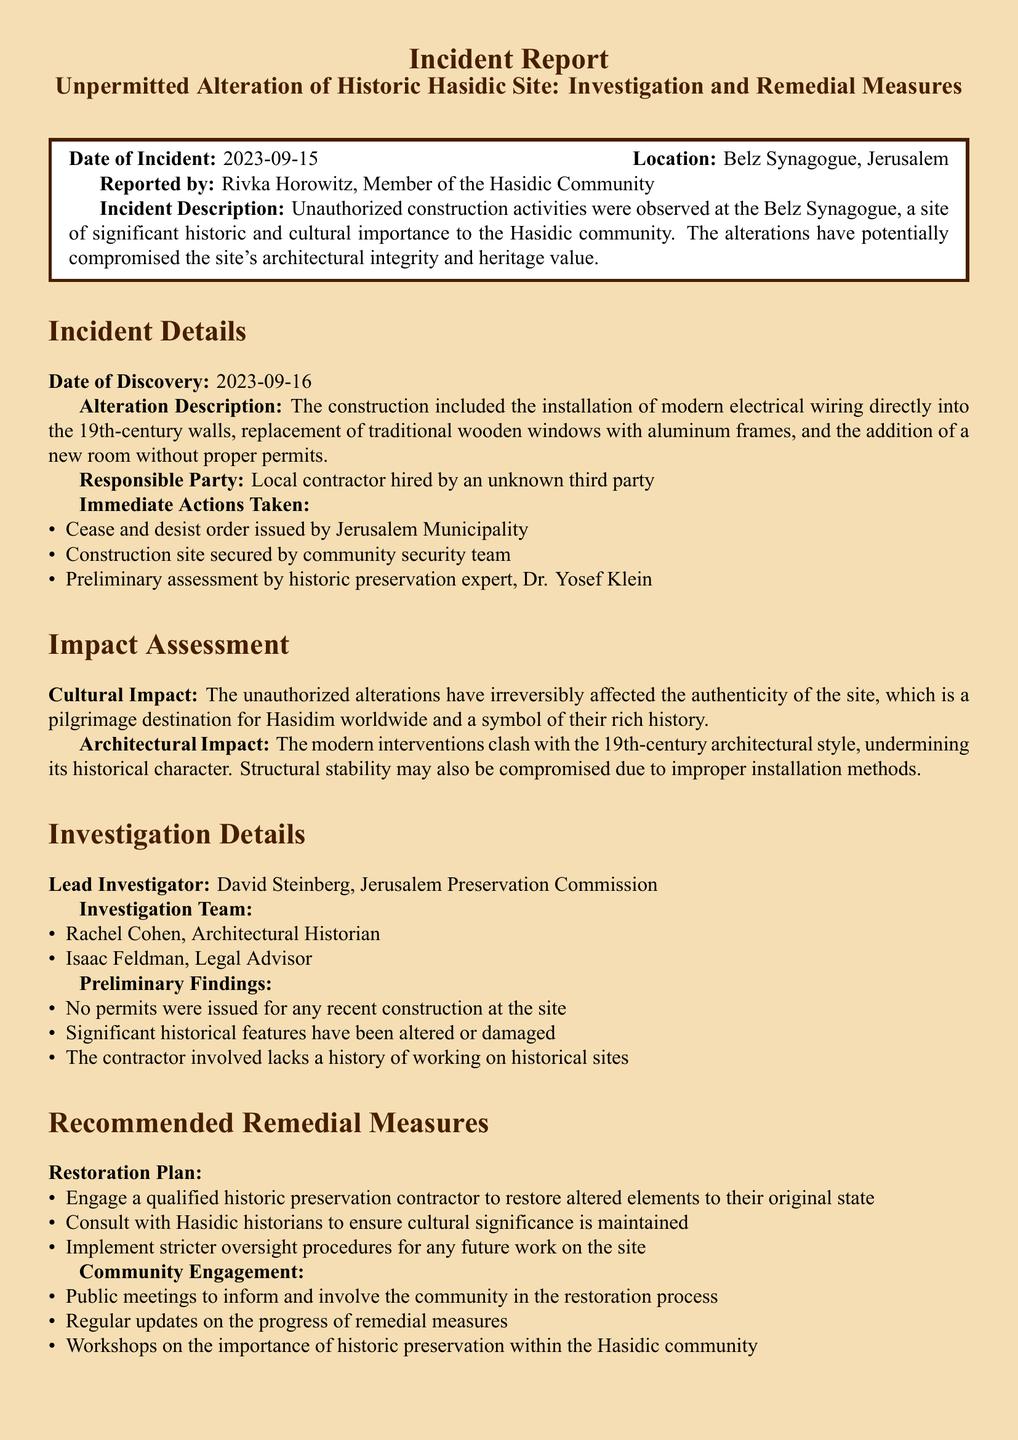what is the date of the incident? The date of the incident is mentioned prominently in the report as the day it occurred, which is September 15, 2023.
Answer: 2023-09-15 where is the location of the incident? The report specifies the location where the incident took place, which is a historic site known to the Hasidic community.
Answer: Belz Synagogue, Jerusalem who reported the incident? The report includes the name of the individual who reported the incident, highlighting their community ties.
Answer: Rivka Horowitz what actions were taken immediately after the incident? The report lists the immediate responses to the incident, detailing steps taken to address the situation.
Answer: Cease and desist order what is the cultural impact of the alterations? The report elaborates on the significance of the site and the effect of the alterations on its cultural heritage.
Answer: Irreversibly affected the authenticity who is the lead investigator for this incident? The document identifies the individual responsible for leading the investigation into the incident.
Answer: David Steinberg what did the preliminary findings reveal about permits? The report emphasizes the lack of proper authorization for the construction activities and their implications.
Answer: No permits were issued what is one recommended remedial measure? The report suggests specific actions aimed at addressing the unauthorized alterations to restore the site's integrity.
Answer: Engage a qualified historic preservation contractor what community engagement activities are proposed? The report outlines methods for involving the local community in the restoration process.
Answer: Public meetings to inform and involve 